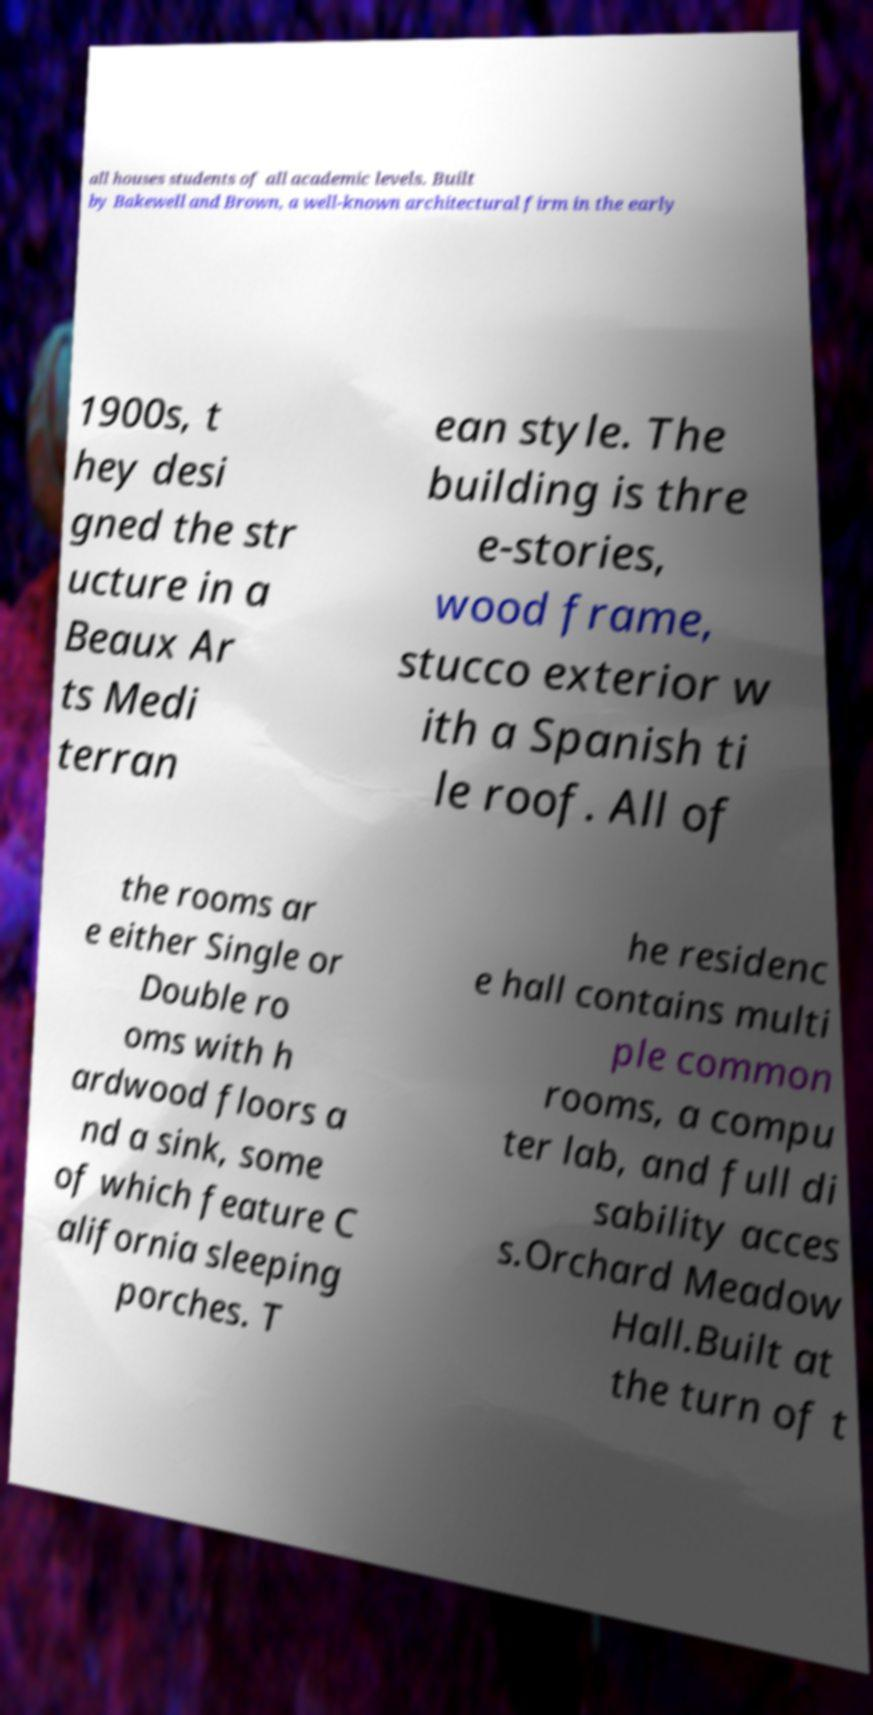Please read and relay the text visible in this image. What does it say? all houses students of all academic levels. Built by Bakewell and Brown, a well-known architectural firm in the early 1900s, t hey desi gned the str ucture in a Beaux Ar ts Medi terran ean style. The building is thre e-stories, wood frame, stucco exterior w ith a Spanish ti le roof. All of the rooms ar e either Single or Double ro oms with h ardwood floors a nd a sink, some of which feature C alifornia sleeping porches. T he residenc e hall contains multi ple common rooms, a compu ter lab, and full di sability acces s.Orchard Meadow Hall.Built at the turn of t 